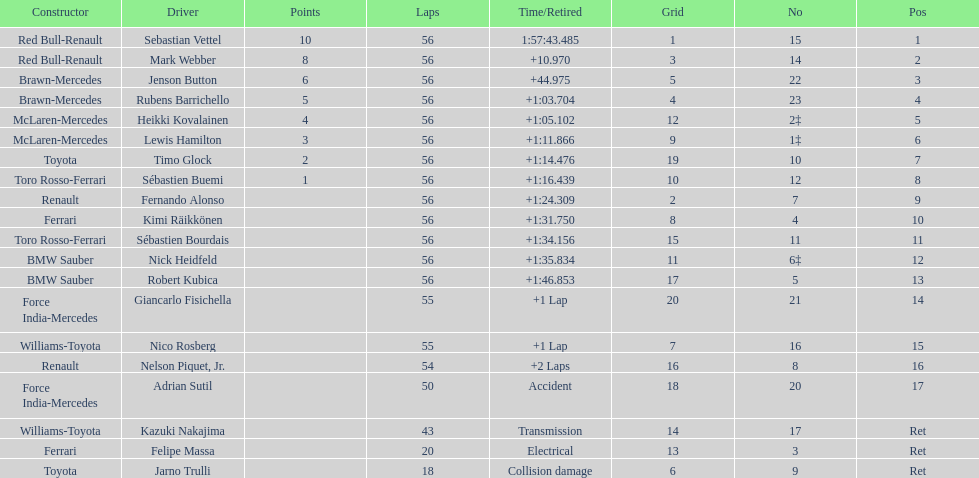What was jenson button's time? +44.975. 